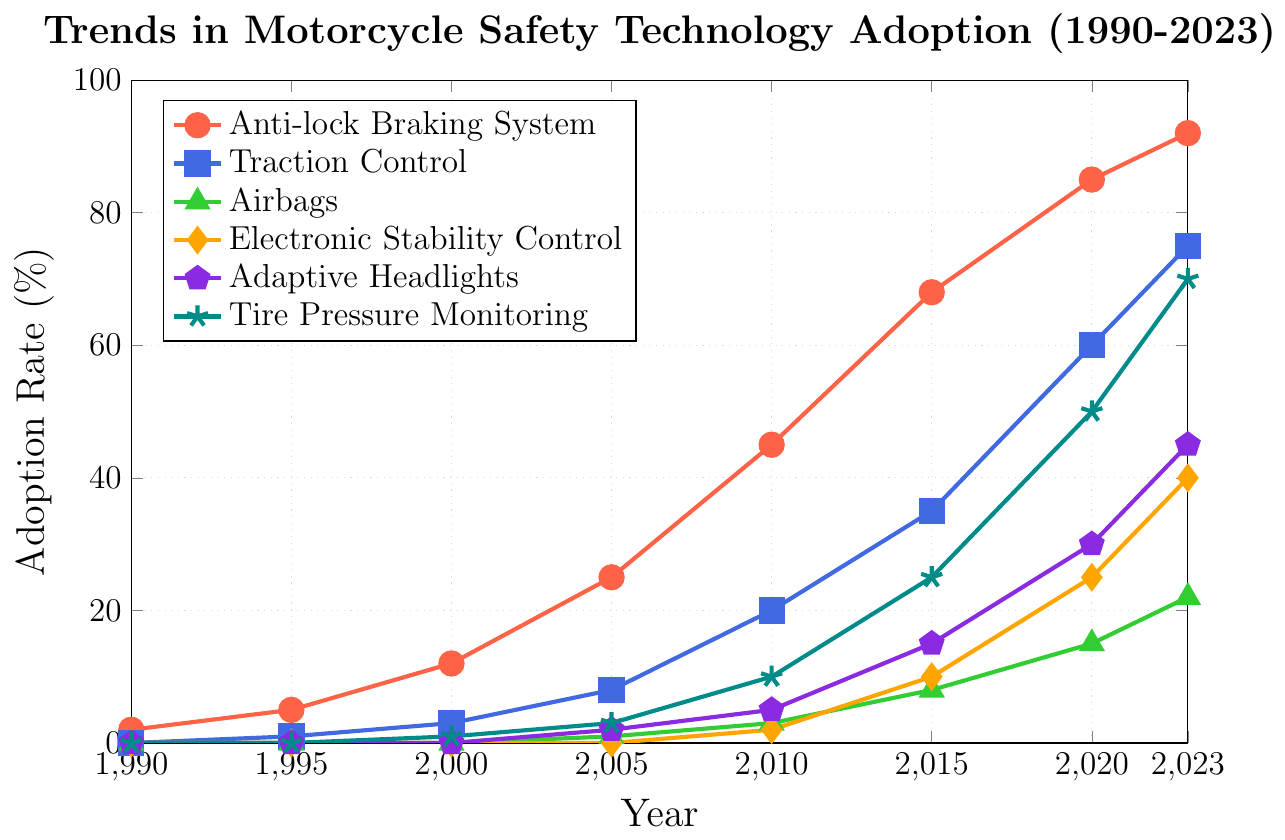What feature had the highest adoption rate in 2023? The Anti-lock Braking System (ABS) has the highest adoption rate in 2023. Looking at the figure, the red line representing ABS reaches the highest value on the y-axis at the year 2023, at about 92%.
Answer: Anti-lock Braking System (92%) Which feature showed the largest increase in adoption rate between 2000 and 2023? The table provides us with the adoption rates for the year 2000 and 2023 for each feature. The Anti-lock Braking System (ABS) increased from 12% to 92%, a difference of 80%. Traction Control increased from 3% to 75%, a difference of 72%. The feature with the largest increase is ABS with an 80% increase.
Answer: Anti-lock Braking System What is the sum of the adoption rates for Anti-lock Braking System and Traction Control in 2023? In 2023, the adoption rates for ABS and Traction Control are 92% and 75%, respectively. Summing these values gives us 92 + 75 = 167.
Answer: 167% How did the adoption rate of Airbags compare to that of Electronic Stability Control in 2015? In 2015, Airbags had an adoption rate of 8%, while Electronic Stability Control had an adoption rate of 10%. Thus, Electronic Stability Control's adoption rate was higher than that of Airbags in 2015.
Answer: Electronic Stability Control (10%) > Airbags (8%) Between which years did Tire Pressure Monitoring show the most significant increase? To determine this, compare the adoption rates at each year checkpoint. The most significant increase for Tire Pressure Monitoring occurs between 2015 (25%) and 2020 (50%), an increase of 25 percentage points.
Answer: 2015 to 2020 Which feature reached a 50% adoption rate first? As per the figure, Traction Control reached a 50% adoption rate by 2020. No other feature reaches 50% before this year.
Answer: Traction Control What is the average adoption rate of Adaptive Headlights between 2005 and 2023? The values for Adaptive Headlights in the given years are 2 (2005), 5 (2010), 15 (2015), 30 (2020), and 45 (2023). Sum these values: 2 + 5 + 15 + 30 + 45 = 97. The average is 97 / 5 = 19.4.
Answer: 19.4% Which safety feature had no adoption in 1995 but demonstrated a consistent increase afterward? Electronic Stability Control had no adoption in 1995 and showed consistent increases afterward.
Answer: Electronic Stability Control 